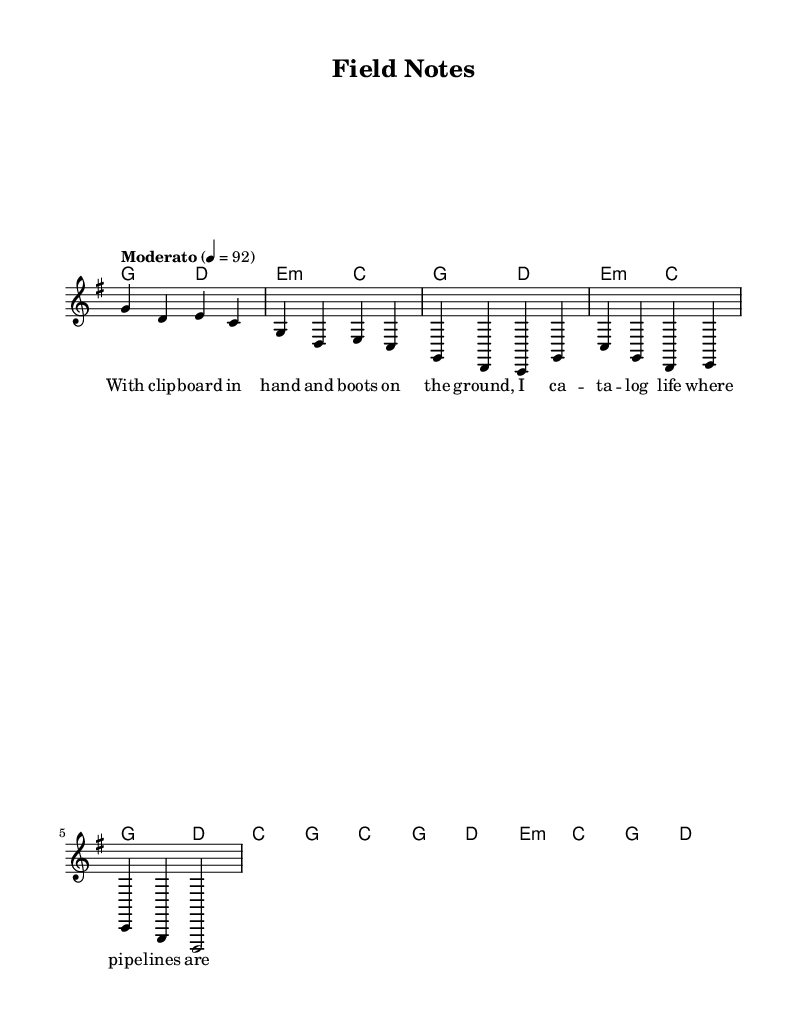What is the key signature of this music? The key signature indicated by the music is G major, which has one sharp (F#). This is determined by observing the key signature notation at the beginning of the score.
Answer: G major What is the time signature of this music? The time signature shown at the start of the music is 4/4, meaning there are four beats in each measure and the quarter note gets one beat. This can be identified by the "4/4" notation next to the clef.
Answer: 4/4 What is the tempo marking for this piece? The tempo marking is indicated as "Moderato" with a metronome marking of 92. This information can be found in the tempo indication placed near the beginning of the score.
Answer: Moderato 92 How many measures are in the chorus? The chorus section consists of two measures, as evident from the notation of the melody and chords, which shows two complete phrases grouped in that section.
Answer: 2 What does the first line of the lyrics refer to? The first line refers to fieldwork in wildlife biology, specifically mentioning cataloging life indicative of environmental monitoring. This can be inferred from the context of the lyrics focused on conservation and field notes.
Answer: Cataloging life What type of song structure is used in this piece? This piece follows a verse-chorus structure, where the opening lyric represents the verse and is followed by the recurring chorus that conveys a central theme. The separation of these sections in the notation indicates this structure.
Answer: Verse-chorus 